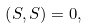<formula> <loc_0><loc_0><loc_500><loc_500>\left ( S , S \right ) = 0 ,</formula> 